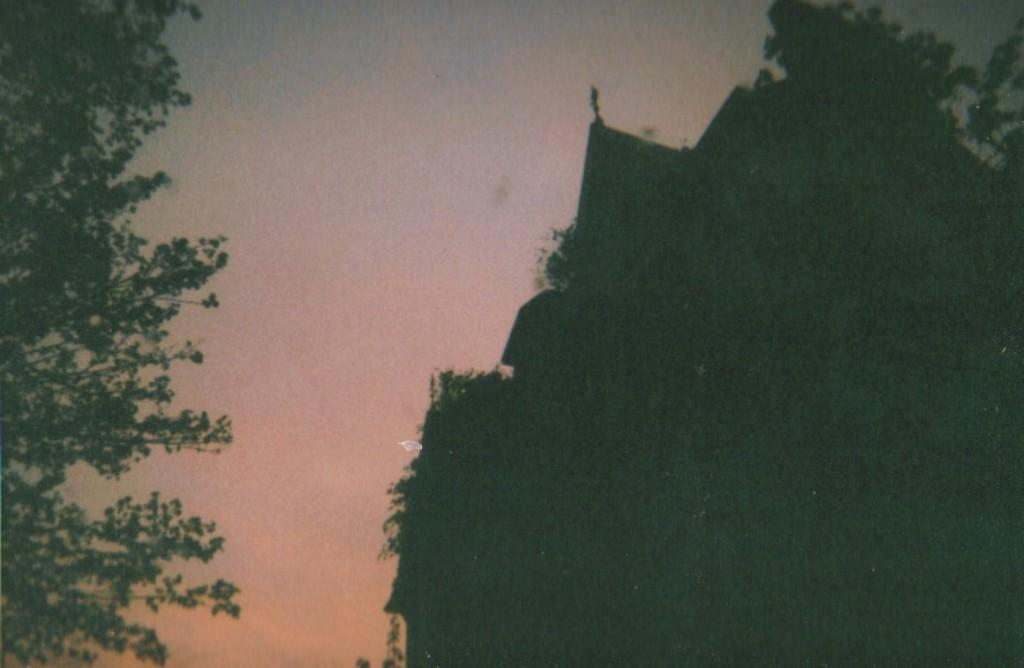What type of vegetation can be seen on the right side of the image? There are trees on the right side of the image. What type of vegetation can be seen on the left side of the image? There are trees on the left side of the image. What is visible in the background of the image? The sky is visible in the background of the image. What type of silver carpenter tool can be seen in the image? There is no carpenter tool or silver present in the image. 